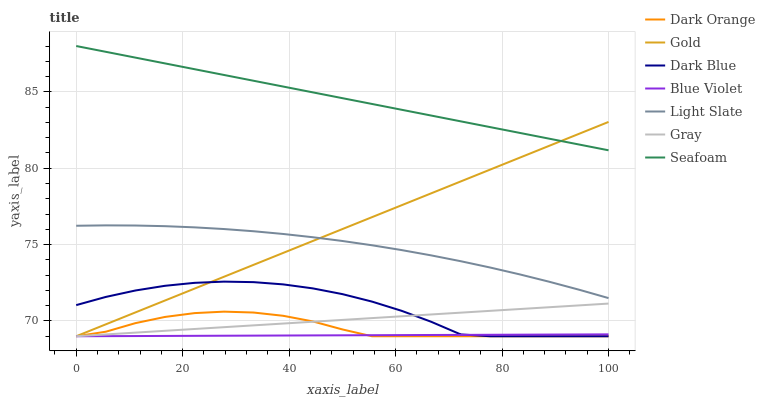Does Blue Violet have the minimum area under the curve?
Answer yes or no. Yes. Does Seafoam have the maximum area under the curve?
Answer yes or no. Yes. Does Gold have the minimum area under the curve?
Answer yes or no. No. Does Gold have the maximum area under the curve?
Answer yes or no. No. Is Seafoam the smoothest?
Answer yes or no. Yes. Is Dark Blue the roughest?
Answer yes or no. Yes. Is Gold the smoothest?
Answer yes or no. No. Is Gold the roughest?
Answer yes or no. No. Does Dark Orange have the lowest value?
Answer yes or no. Yes. Does Light Slate have the lowest value?
Answer yes or no. No. Does Seafoam have the highest value?
Answer yes or no. Yes. Does Gold have the highest value?
Answer yes or no. No. Is Gray less than Light Slate?
Answer yes or no. Yes. Is Seafoam greater than Light Slate?
Answer yes or no. Yes. Does Gold intersect Light Slate?
Answer yes or no. Yes. Is Gold less than Light Slate?
Answer yes or no. No. Is Gold greater than Light Slate?
Answer yes or no. No. Does Gray intersect Light Slate?
Answer yes or no. No. 